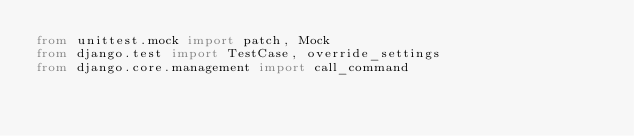Convert code to text. <code><loc_0><loc_0><loc_500><loc_500><_Python_>from unittest.mock import patch, Mock
from django.test import TestCase, override_settings
from django.core.management import call_command</code> 